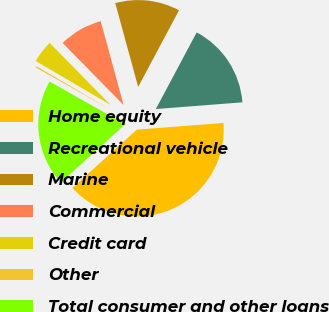Convert chart. <chart><loc_0><loc_0><loc_500><loc_500><pie_chart><fcel>Home equity<fcel>Recreational vehicle<fcel>Marine<fcel>Commercial<fcel>Credit card<fcel>Other<fcel>Total consumer and other loans<nl><fcel>39.52%<fcel>15.97%<fcel>12.04%<fcel>8.12%<fcel>4.19%<fcel>0.26%<fcel>19.89%<nl></chart> 